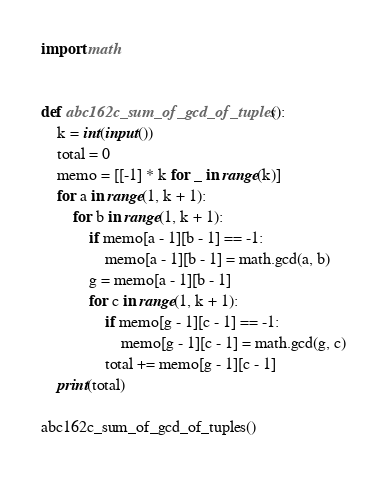<code> <loc_0><loc_0><loc_500><loc_500><_Python_>import math


def abc162c_sum_of_gcd_of_tuples():
    k = int(input())
    total = 0
    memo = [[-1] * k for _ in range(k)]
    for a in range(1, k + 1):
        for b in range(1, k + 1):
            if memo[a - 1][b - 1] == -1:
                memo[a - 1][b - 1] = math.gcd(a, b)
            g = memo[a - 1][b - 1]
            for c in range(1, k + 1):
                if memo[g - 1][c - 1] == -1:
                    memo[g - 1][c - 1] = math.gcd(g, c)
                total += memo[g - 1][c - 1]
    print(total)

abc162c_sum_of_gcd_of_tuples()</code> 